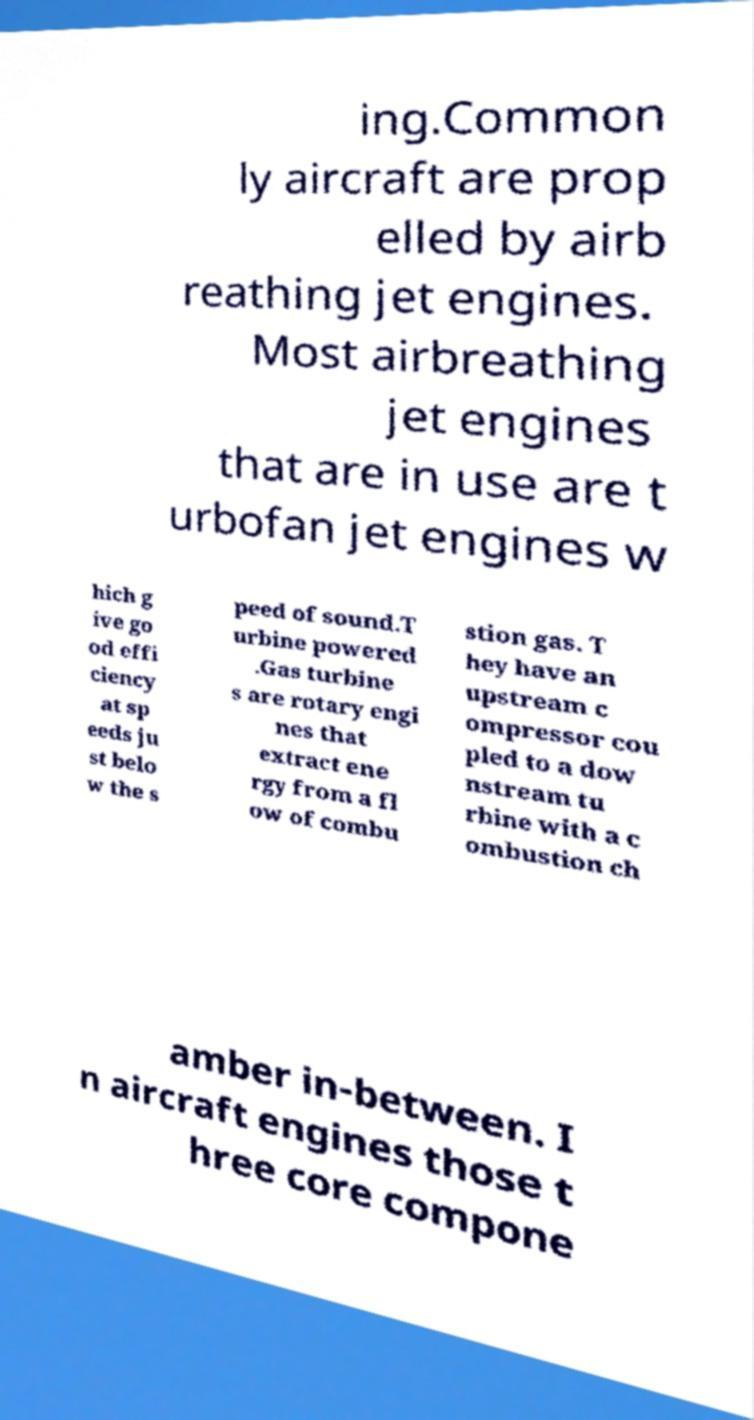Could you assist in decoding the text presented in this image and type it out clearly? ing.Common ly aircraft are prop elled by airb reathing jet engines. Most airbreathing jet engines that are in use are t urbofan jet engines w hich g ive go od effi ciency at sp eeds ju st belo w the s peed of sound.T urbine powered .Gas turbine s are rotary engi nes that extract ene rgy from a fl ow of combu stion gas. T hey have an upstream c ompressor cou pled to a dow nstream tu rbine with a c ombustion ch amber in-between. I n aircraft engines those t hree core compone 